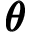Convert formula to latex. <formula><loc_0><loc_0><loc_500><loc_500>\pm b { \theta }</formula> 